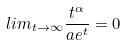<formula> <loc_0><loc_0><loc_500><loc_500>l i m _ { t \rightarrow \infty } \frac { t ^ { \alpha } } { a e ^ { t } } = 0</formula> 